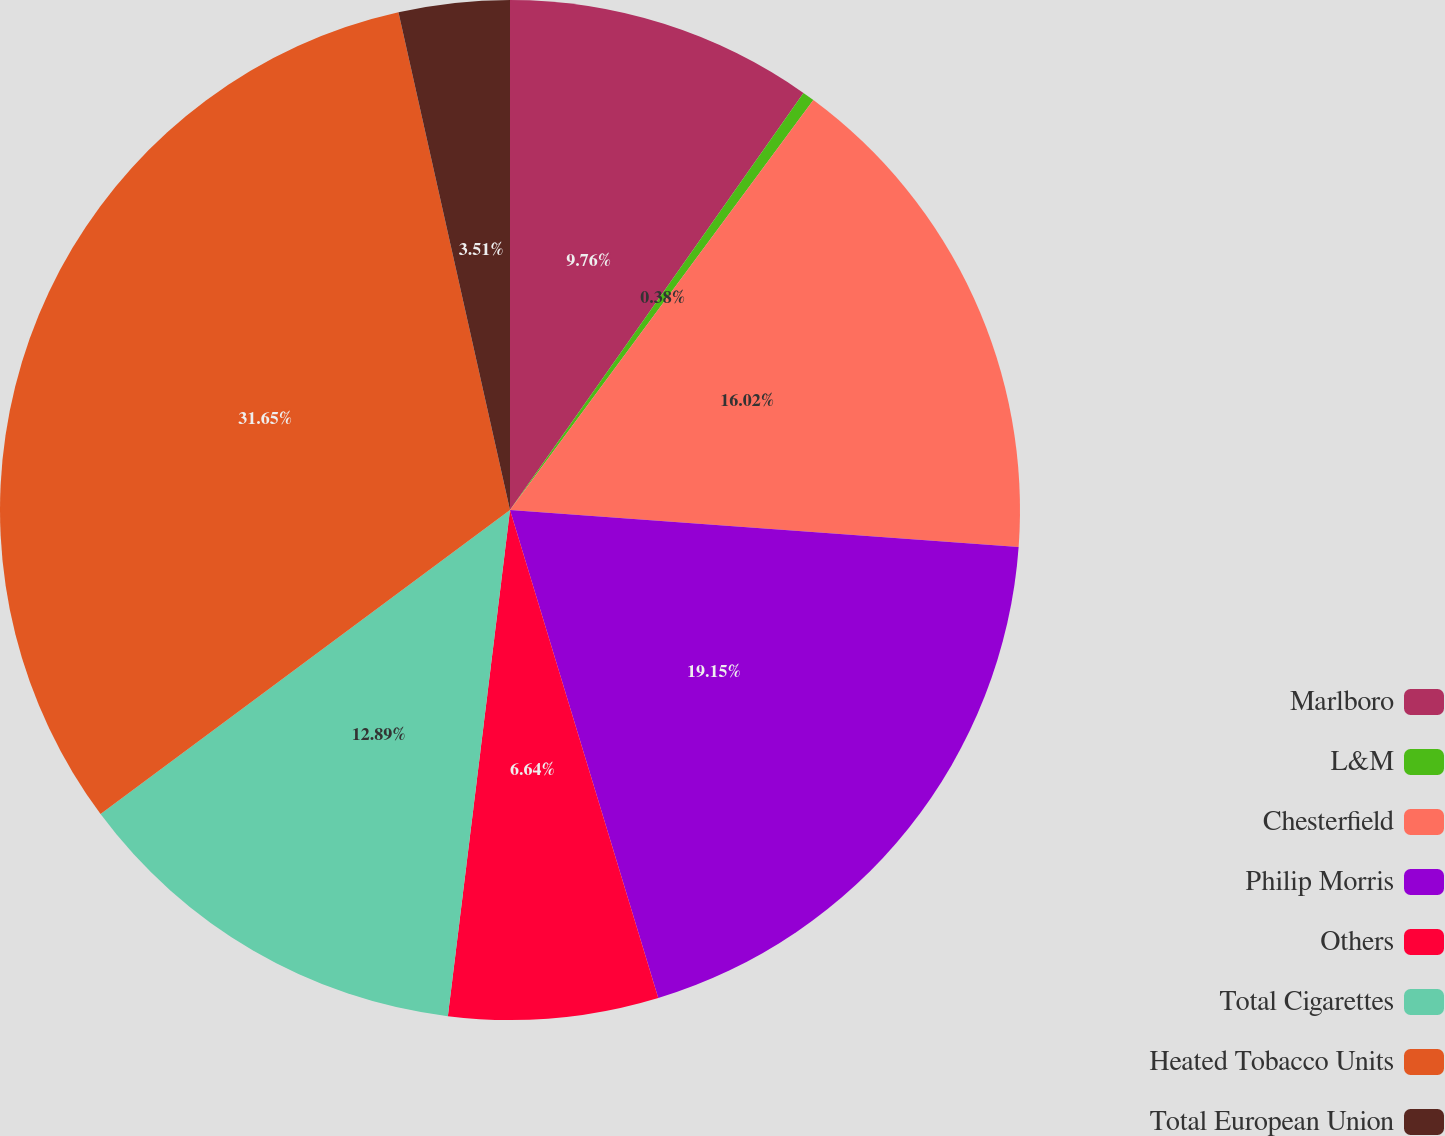<chart> <loc_0><loc_0><loc_500><loc_500><pie_chart><fcel>Marlboro<fcel>L&M<fcel>Chesterfield<fcel>Philip Morris<fcel>Others<fcel>Total Cigarettes<fcel>Heated Tobacco Units<fcel>Total European Union<nl><fcel>9.76%<fcel>0.38%<fcel>16.02%<fcel>19.15%<fcel>6.64%<fcel>12.89%<fcel>31.66%<fcel>3.51%<nl></chart> 